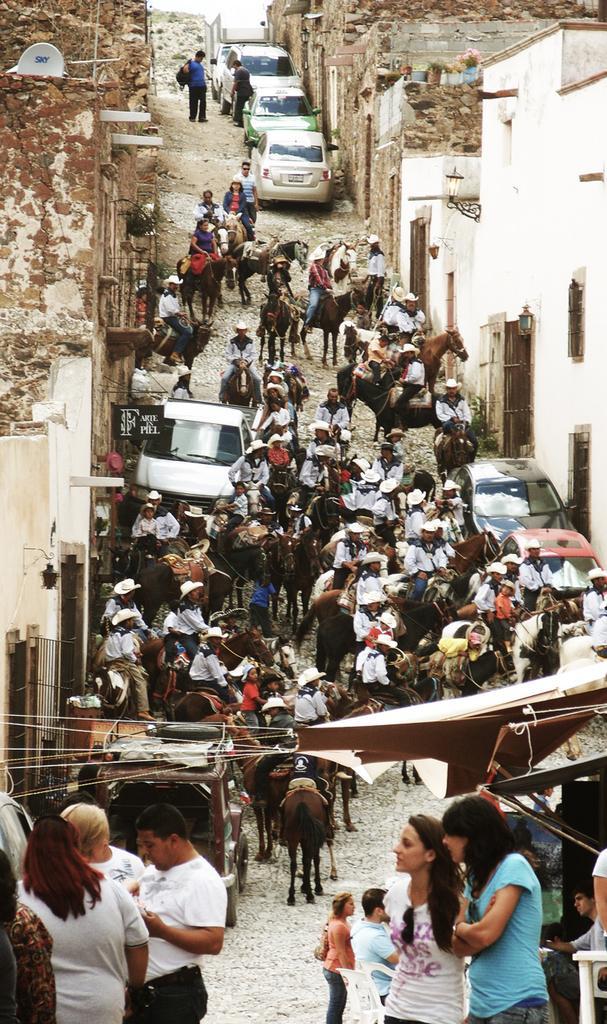Can you describe this image briefly? This picture shows a group of people riding horses in a lane ,we see few cars parked on the side. 